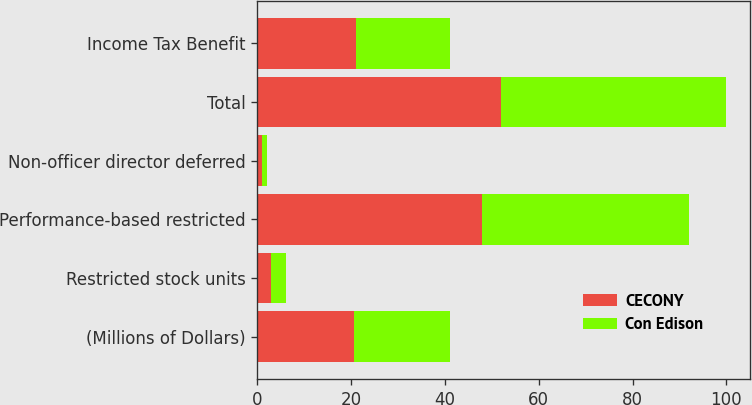Convert chart to OTSL. <chart><loc_0><loc_0><loc_500><loc_500><stacked_bar_chart><ecel><fcel>(Millions of Dollars)<fcel>Restricted stock units<fcel>Performance-based restricted<fcel>Non-officer director deferred<fcel>Total<fcel>Income Tax Benefit<nl><fcel>CECONY<fcel>20.5<fcel>3<fcel>48<fcel>1<fcel>52<fcel>21<nl><fcel>Con Edison<fcel>20.5<fcel>3<fcel>44<fcel>1<fcel>48<fcel>20<nl></chart> 